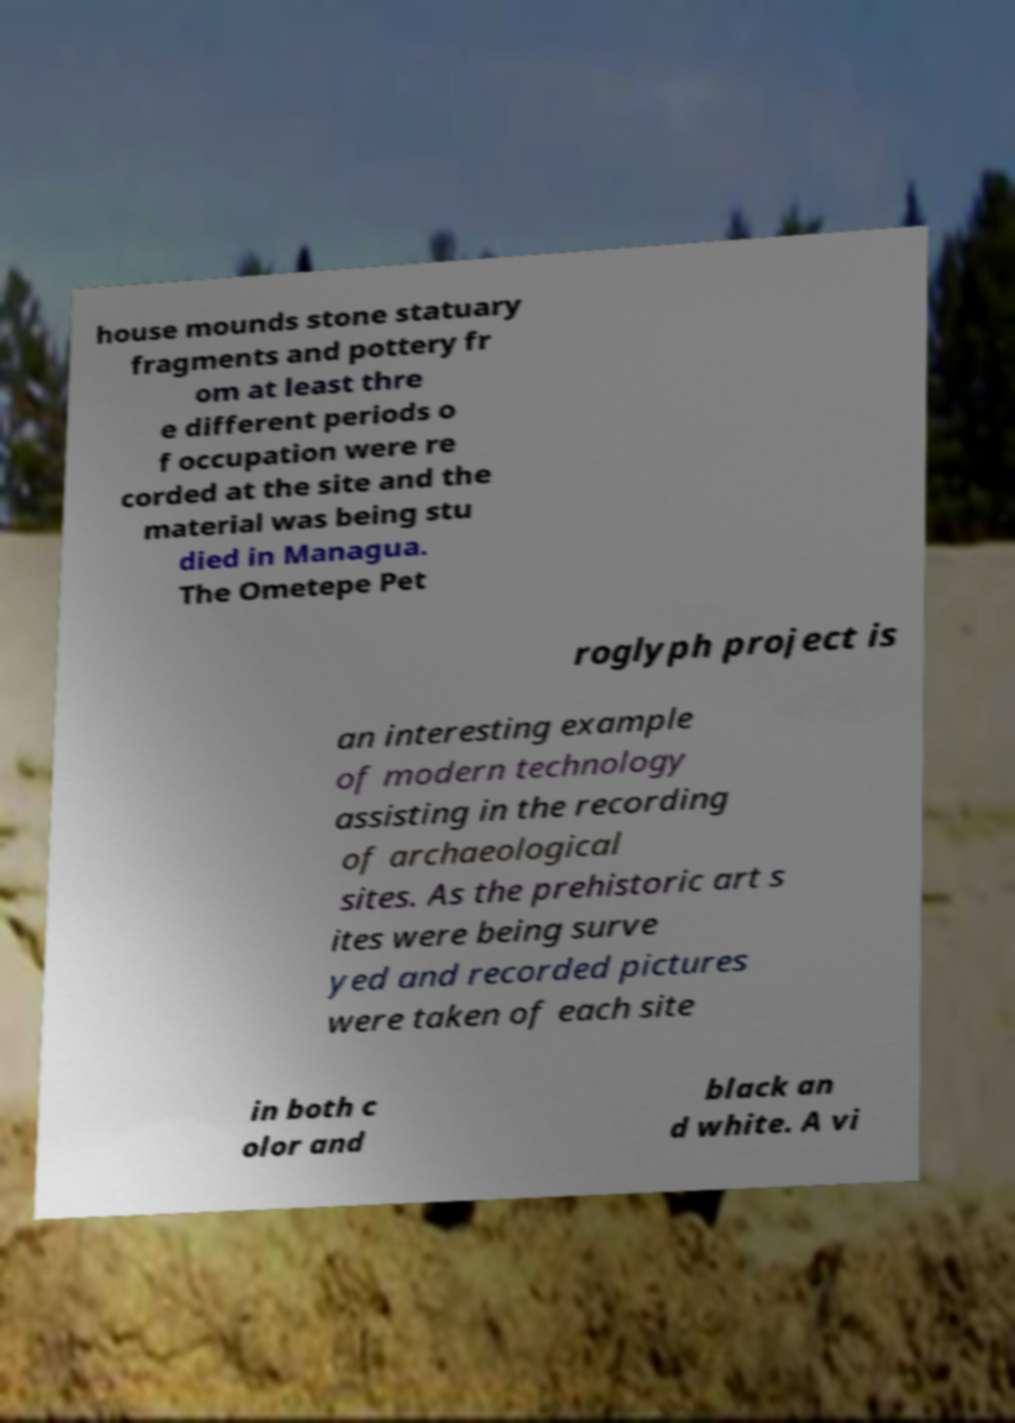There's text embedded in this image that I need extracted. Can you transcribe it verbatim? house mounds stone statuary fragments and pottery fr om at least thre e different periods o f occupation were re corded at the site and the material was being stu died in Managua. The Ometepe Pet roglyph project is an interesting example of modern technology assisting in the recording of archaeological sites. As the prehistoric art s ites were being surve yed and recorded pictures were taken of each site in both c olor and black an d white. A vi 